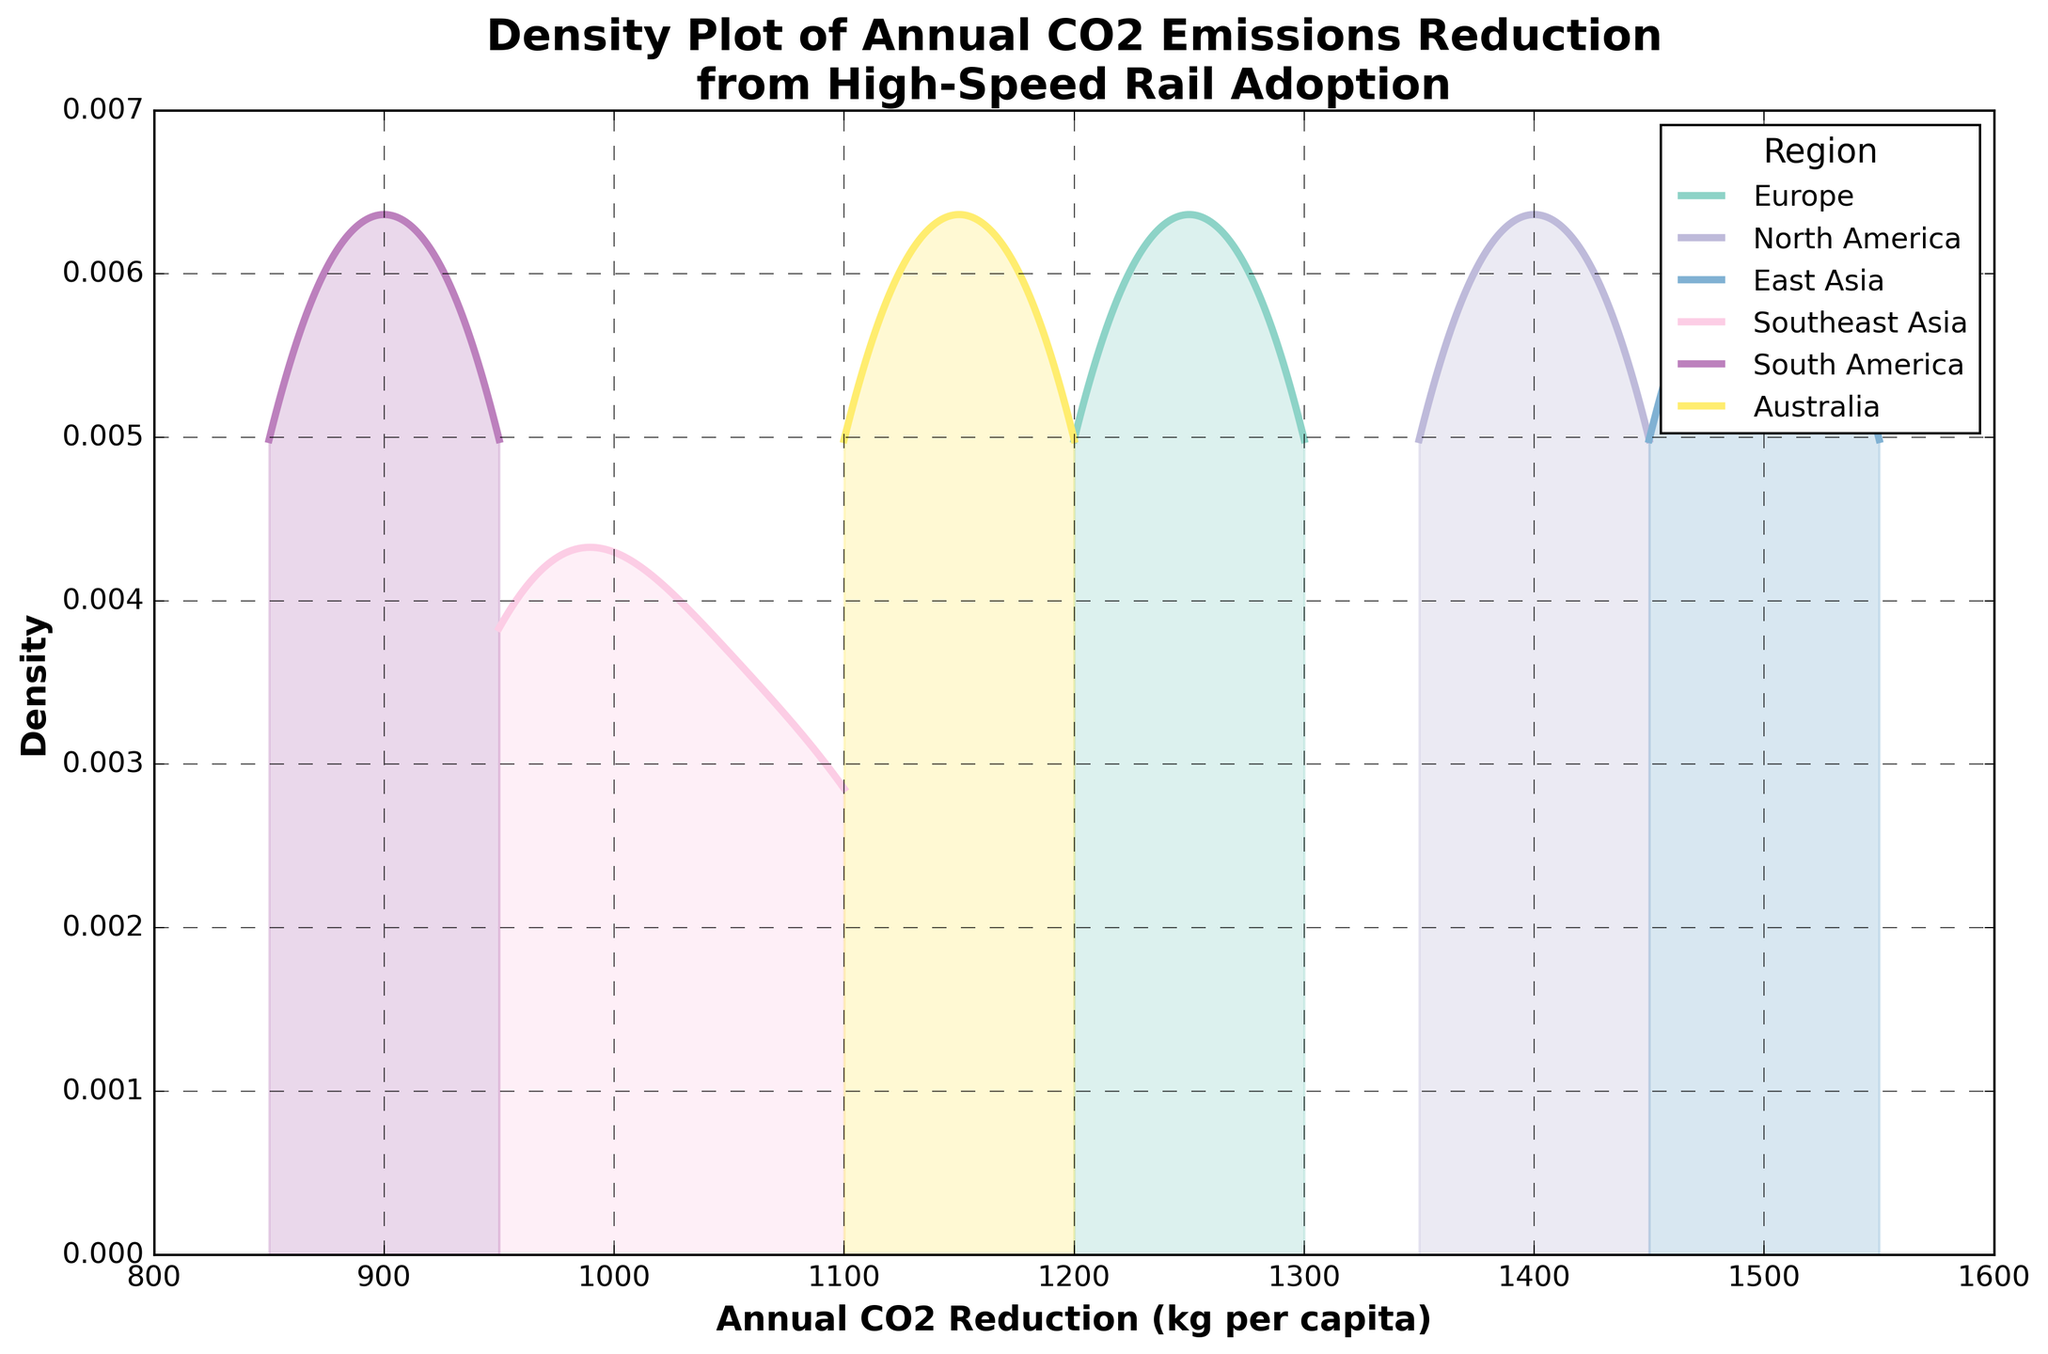What is the title of the plot? The title is displayed at the top of the plot. Reading it directly will provide the answer.
Answer: Density Plot of Annual CO2 Emissions Reduction from High-Speed Rail Adoption Which region has the highest peak density in CO2 reduction? The highest peak can be identified by finding the region where the density curve reaches its maximum value on the y-axis.
Answer: East Asia What is the x-axis labeled as? The x-axis label is written directly below the horizontal axis. Reading it directly provides the answer.
Answer: Annual CO2 Reduction (kg per capita) Between which values does the x-axis range? Observing the values at the minimum and maximum extents of the x-axis provides the required range.
Answer: 800 to 1600 Which region shows the lowest average CO2 reduction? By inspecting each region's density curve, the region with the overall lowest curve will indicate the lowest average reduction.
Answer: South America How does North America's CO2 reduction density compare to Europe's? Comparing the peaks and shapes of the density curves for North America and Europe will show their differences. North America's peak is higher and farther to the right than Europe's.
Answer: North America has higher density and larger CO2 reduction Around which value does Southeast Asia's density peak? Observing the highest point of the density curve for Southeast Asia will give the value at which its density peaks.
Answer: Around 1000 kg per capita In terms of annual CO2 reduction, which region's distribution has the widest spread? The region with the most extended range on the x-axis from the density plot indicates the widest spread.
Answer: North America Is Australia's peak density higher or lower than Europe's? Comparing the peak heights of the density curves for Australia and Europe will ascertain which is higher.
Answer: Lower What can you infer about the CO2 reduction in East Asia compared to other regions? By observing East Asia's density curve which peaks higher and further right than others, it can be inferred that East Asia has generally higher CO2 reductions.
Answer: East Asia has higher CO2 reductions than other regions 